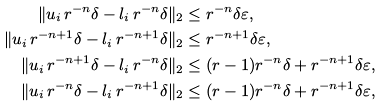Convert formula to latex. <formula><loc_0><loc_0><loc_500><loc_500>\| u _ { i } \, r ^ { - n } \delta - l _ { i } \, r ^ { - n } \delta \| _ { 2 } & \leq r ^ { - n } \delta \varepsilon , \\ \| u _ { i } \, r ^ { - n + 1 } \delta - l _ { i } \, r ^ { - n + 1 } \delta \| _ { 2 } & \leq r ^ { - n + 1 } \delta \varepsilon , \\ \| u _ { i } \, r ^ { - n + 1 } \delta - l _ { i } \, r ^ { - n } \delta \| _ { 2 } & \leq ( r - 1 ) r ^ { - n } \delta + r ^ { - n + 1 } \delta \varepsilon , \\ \| u _ { i } \, r ^ { - n } \delta - l _ { i } \, r ^ { - n + 1 } \delta \| _ { 2 } & \leq ( r - 1 ) r ^ { - n } \delta + r ^ { - n + 1 } \delta \varepsilon ,</formula> 